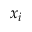<formula> <loc_0><loc_0><loc_500><loc_500>x _ { i }</formula> 